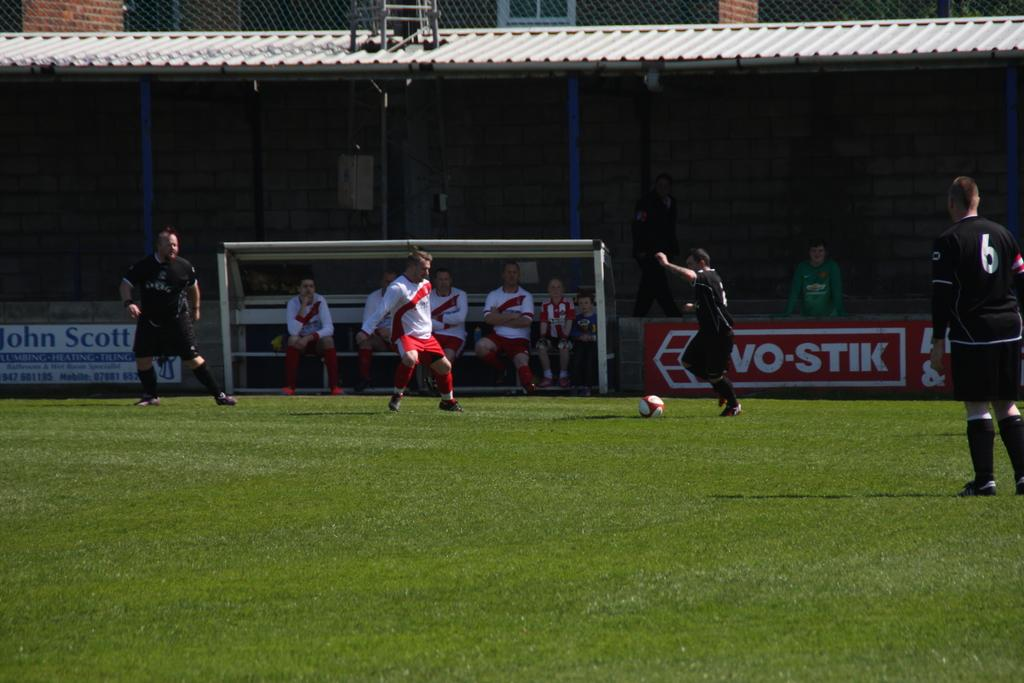<image>
Give a short and clear explanation of the subsequent image. An ad for John Scott lines a soccer field where there is a game going on. 